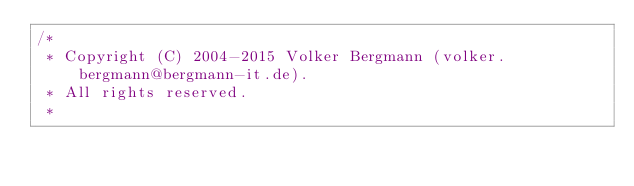<code> <loc_0><loc_0><loc_500><loc_500><_Java_>/*
 * Copyright (C) 2004-2015 Volker Bergmann (volker.bergmann@bergmann-it.de).
 * All rights reserved.
 *</code> 